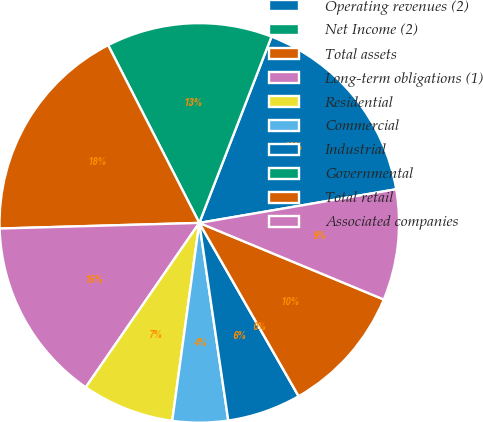<chart> <loc_0><loc_0><loc_500><loc_500><pie_chart><fcel>Operating revenues (2)<fcel>Net Income (2)<fcel>Total assets<fcel>Long-term obligations (1)<fcel>Residential<fcel>Commercial<fcel>Industrial<fcel>Governmental<fcel>Total retail<fcel>Associated companies<nl><fcel>16.42%<fcel>13.43%<fcel>17.91%<fcel>14.93%<fcel>7.46%<fcel>4.48%<fcel>5.97%<fcel>0.0%<fcel>10.45%<fcel>8.96%<nl></chart> 